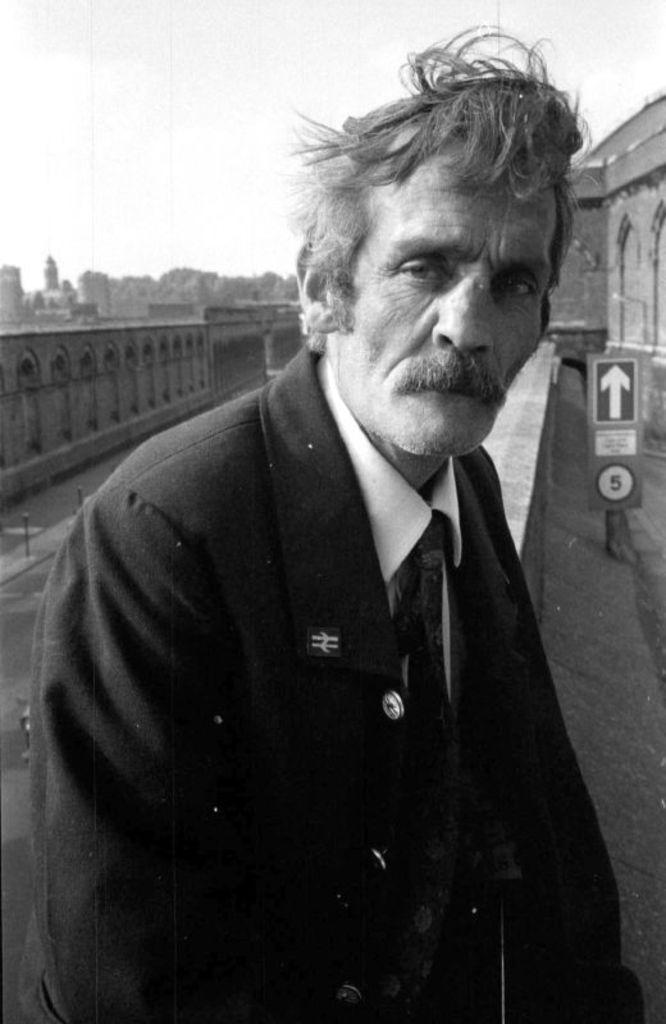What is the man in the image doing? The man is sitting in the image. What is the man wearing? The man is wearing a suit. What can be seen in the background of the image? There is a building in the background of the image. What is the color scheme of the image? The image is in black and white. What is visible at the top of the image? The sky is visible in the image. What type of brake is the man using in the image? There is no brake present in the image; it features a man sitting in a suit. What tools might the carpenter be using in the image? There is no carpenter or tools present in the image; it features a man sitting in a suit. 